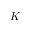Convert formula to latex. <formula><loc_0><loc_0><loc_500><loc_500>K</formula> 